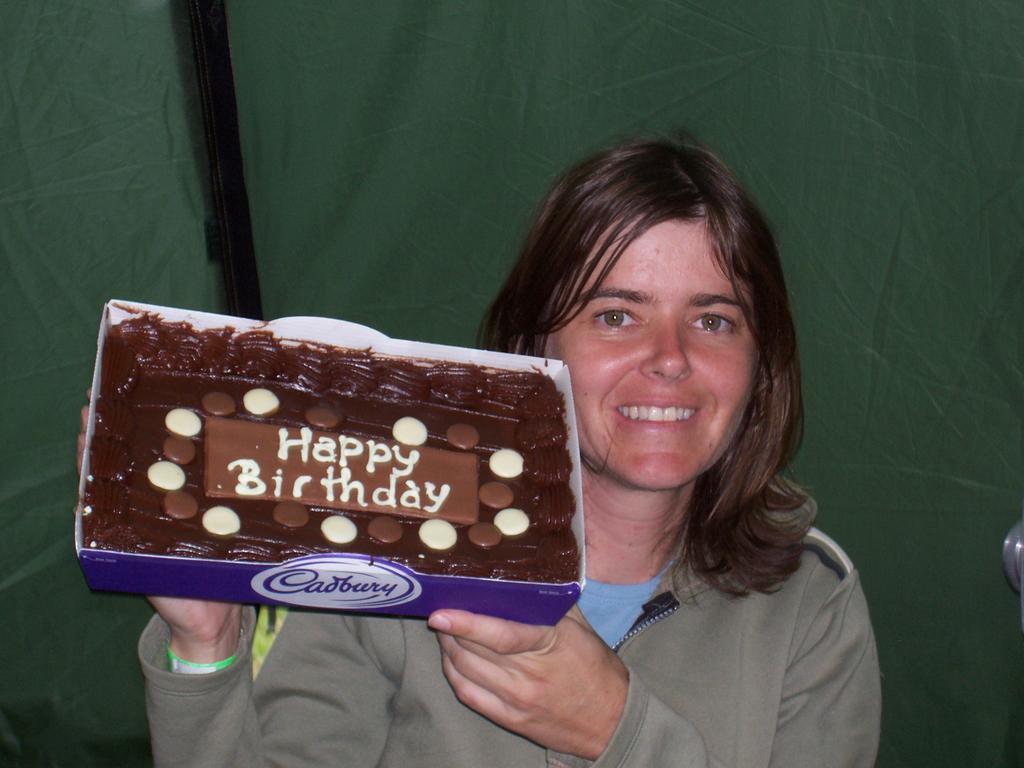How would you summarize this image in a sentence or two? In this picture I can observe a woman. The woman is smiling. She is holding a chocolate pack in her hands. In the background I can observe green color cloth. 